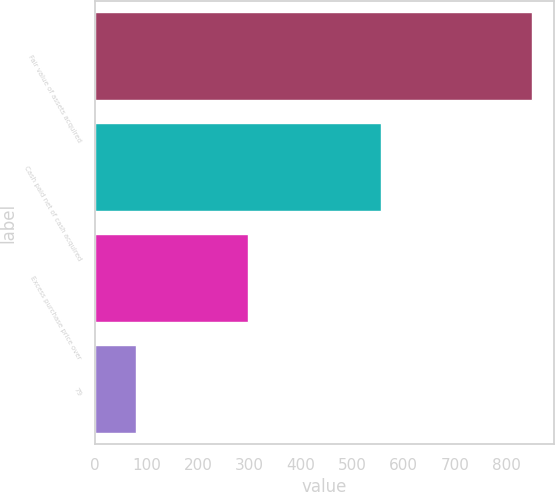Convert chart. <chart><loc_0><loc_0><loc_500><loc_500><bar_chart><fcel>Fair value of assets acquired<fcel>Cash paid net of cash acquired<fcel>Excess purchase price over<fcel>79<nl><fcel>850<fcel>556<fcel>298<fcel>79<nl></chart> 